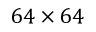Convert formula to latex. <formula><loc_0><loc_0><loc_500><loc_500>6 4 \times 6 4</formula> 